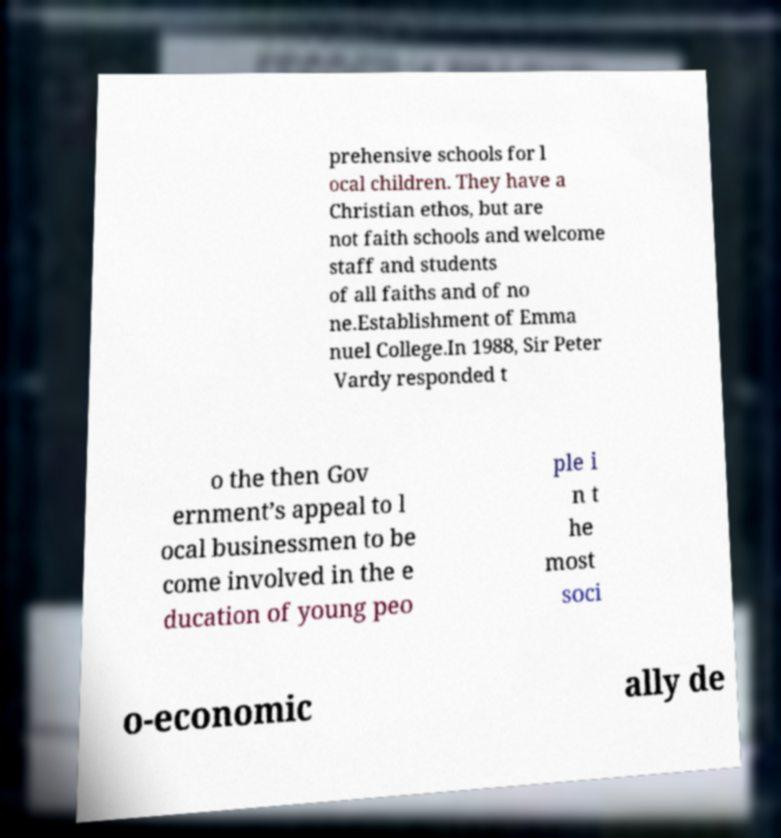There's text embedded in this image that I need extracted. Can you transcribe it verbatim? prehensive schools for l ocal children. They have a Christian ethos, but are not faith schools and welcome staff and students of all faiths and of no ne.Establishment of Emma nuel College.In 1988, Sir Peter Vardy responded t o the then Gov ernment’s appeal to l ocal businessmen to be come involved in the e ducation of young peo ple i n t he most soci o-economic ally de 